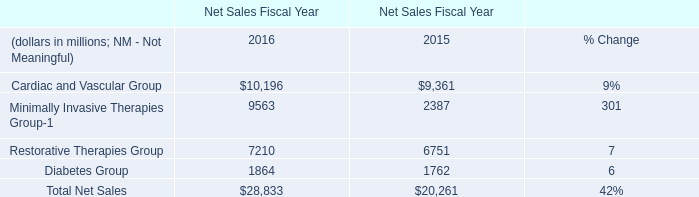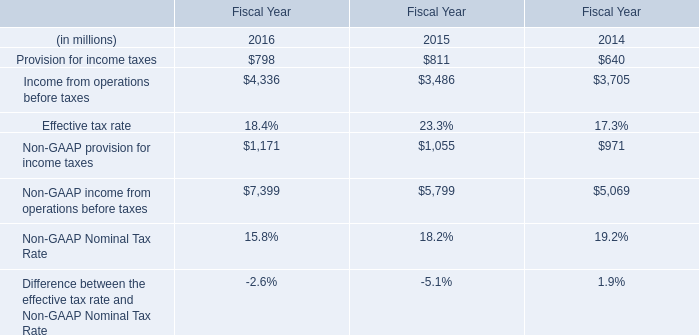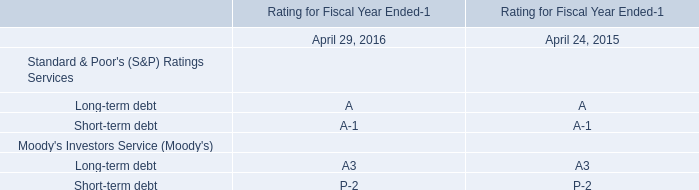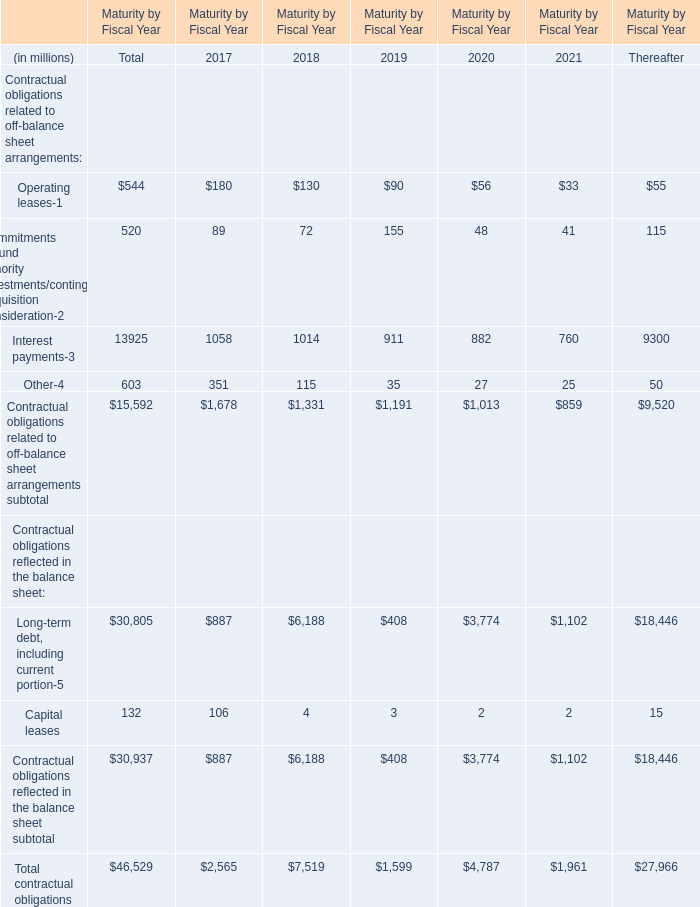What is the total amount of Income from operations before taxes of Fiscal Year 2016, Diabetes Group of Net Sales Fiscal Year 2015, and Minimally Invasive Therapies Group of Net Sales Fiscal Year 2015 ? 
Computations: ((4336.0 + 1762.0) + 2387.0)
Answer: 8485.0. 